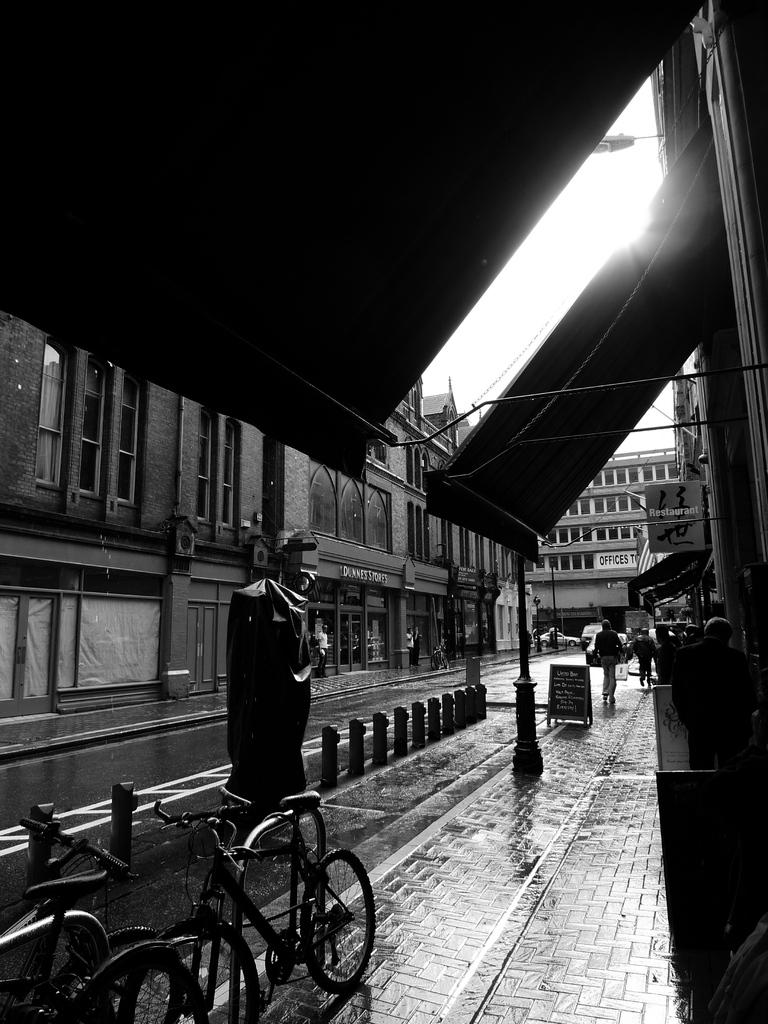What type of vehicles are present in the image? There are bi-cycles in the image. What can be seen happening in the background of the image? There are people walking and stalls in the background of the image. What type of structures are visible in the background of the image? There are buildings in the background of the image. What part of the natural environment is visible in the image? The sky is visible in the image. What is the color scheme of the image? The image is in black and white. What type of bed can be seen in the image? There is no bed present in the image. What smell is associated with the image? The image does not have a smell, as it is a visual representation. 